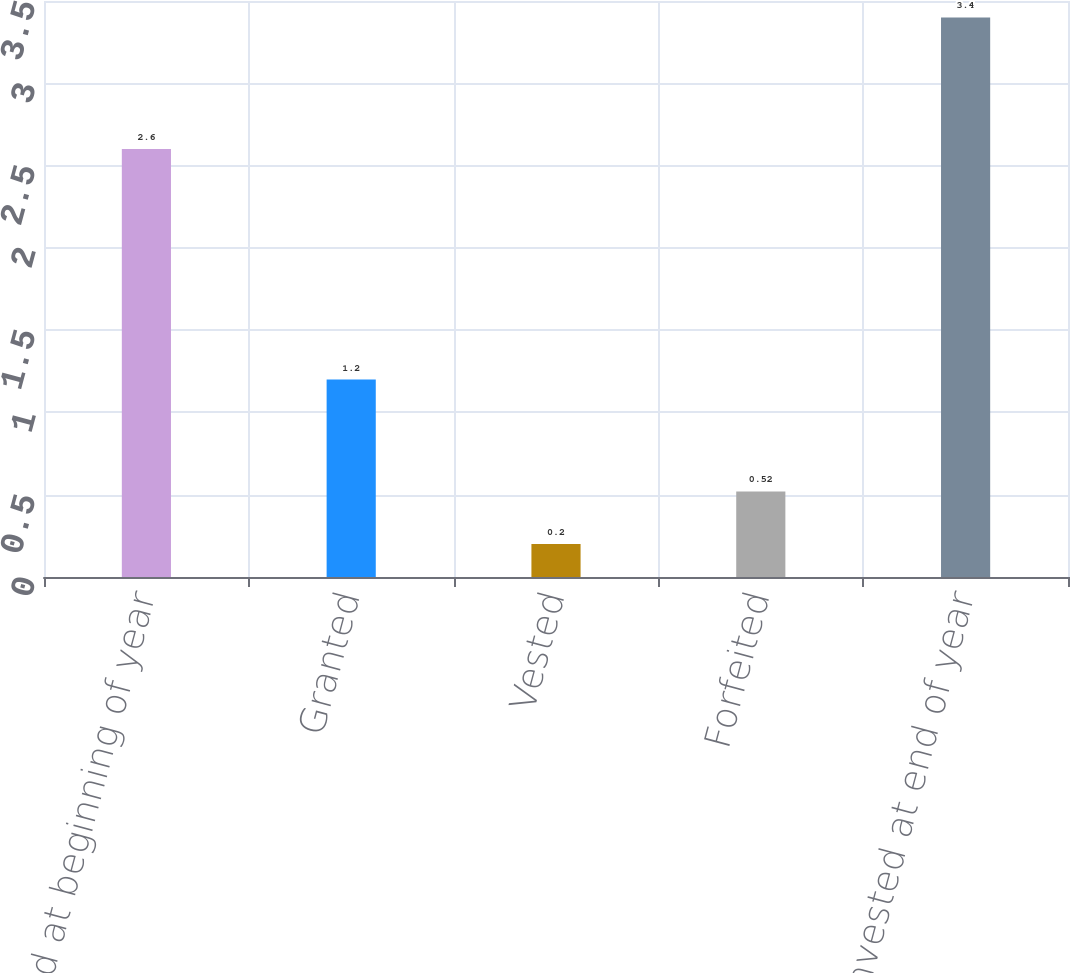Convert chart to OTSL. <chart><loc_0><loc_0><loc_500><loc_500><bar_chart><fcel>Nonvested at beginning of year<fcel>Granted<fcel>Vested<fcel>Forfeited<fcel>Nonvested at end of year<nl><fcel>2.6<fcel>1.2<fcel>0.2<fcel>0.52<fcel>3.4<nl></chart> 